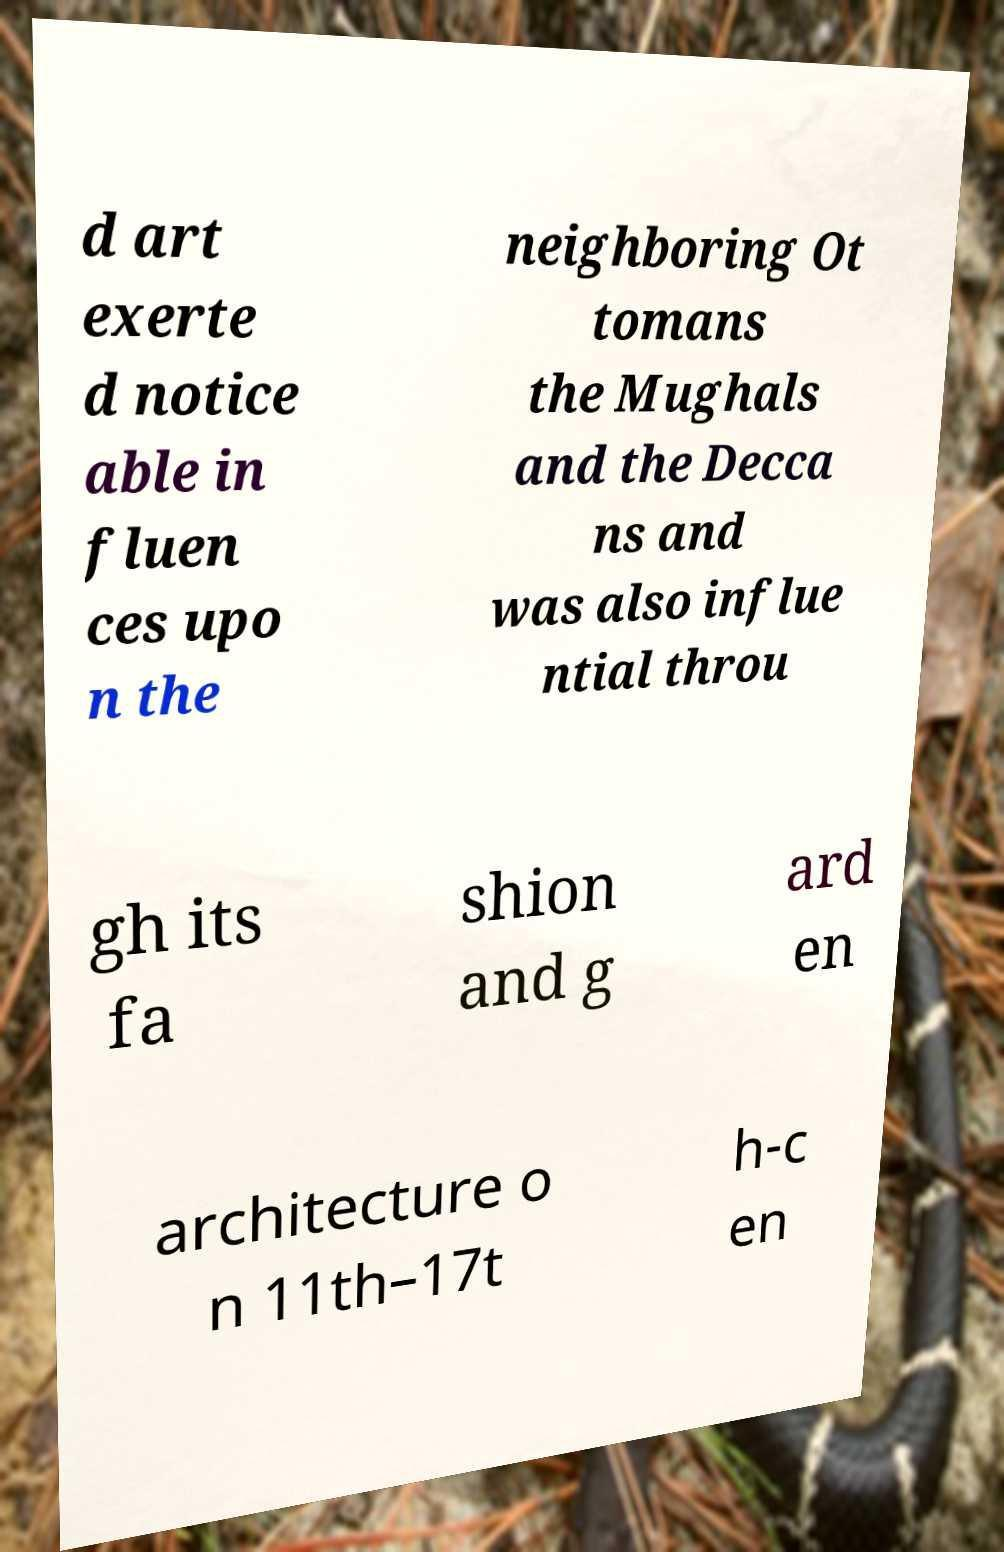There's text embedded in this image that I need extracted. Can you transcribe it verbatim? d art exerte d notice able in fluen ces upo n the neighboring Ot tomans the Mughals and the Decca ns and was also influe ntial throu gh its fa shion and g ard en architecture o n 11th–17t h-c en 